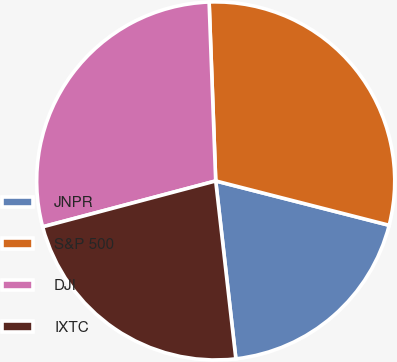<chart> <loc_0><loc_0><loc_500><loc_500><pie_chart><fcel>JNPR<fcel>S&P 500<fcel>DJI<fcel>IXTC<nl><fcel>19.22%<fcel>29.57%<fcel>28.54%<fcel>22.67%<nl></chart> 